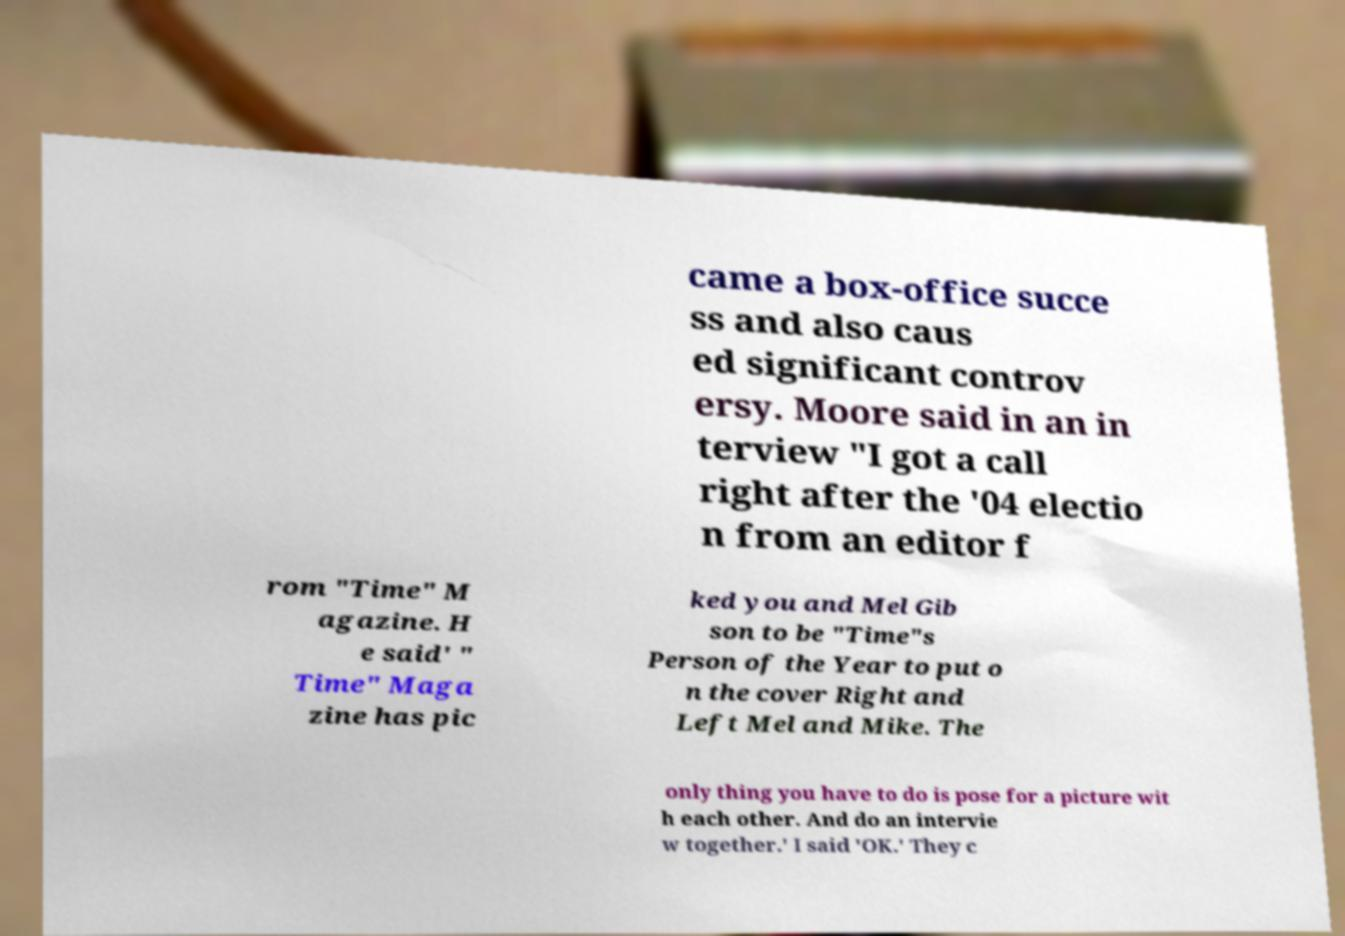Could you assist in decoding the text presented in this image and type it out clearly? came a box-office succe ss and also caus ed significant controv ersy. Moore said in an in terview "I got a call right after the '04 electio n from an editor f rom "Time" M agazine. H e said' " Time" Maga zine has pic ked you and Mel Gib son to be "Time"s Person of the Year to put o n the cover Right and Left Mel and Mike. The only thing you have to do is pose for a picture wit h each other. And do an intervie w together.' I said 'OK.' They c 